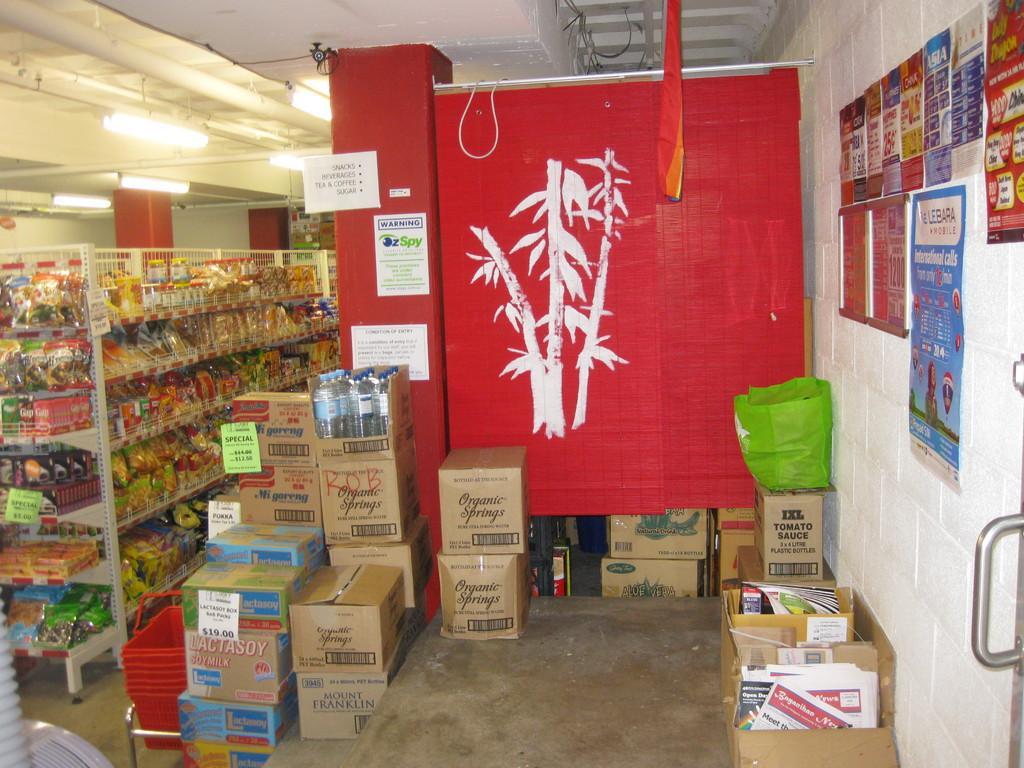In one or two sentences, can you explain what this image depicts? On the right side there is a wall with different posters. Near to that there is a red color board with a painting on that. Near to that there are many boxes on the floor. On the left side there are racks. Inside the racks there are many items. On the ceiling there are lights. In the background there are pillars. 